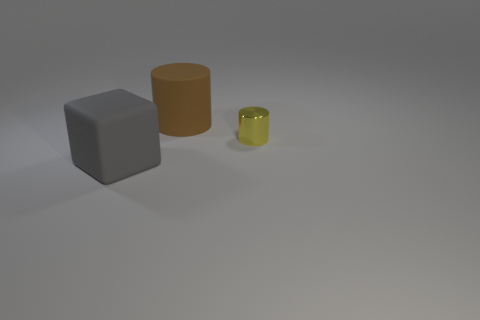The large rubber object that is behind the large block has what shape?
Provide a succinct answer. Cylinder. What is the gray cube made of?
Make the answer very short. Rubber. What is the color of the cylinder that is the same size as the gray block?
Provide a succinct answer. Brown. Does the large brown rubber object have the same shape as the small object?
Provide a short and direct response. Yes. The object that is both in front of the brown rubber cylinder and on the right side of the gray cube is made of what material?
Provide a succinct answer. Metal. The yellow metal object has what size?
Your response must be concise. Small. There is another rubber thing that is the same shape as the yellow object; what color is it?
Provide a succinct answer. Brown. Does the cylinder that is to the left of the small metal object have the same size as the object in front of the shiny cylinder?
Give a very brief answer. Yes. Are there an equal number of tiny metal objects in front of the large matte block and large rubber cubes in front of the big brown thing?
Offer a very short reply. No. Does the matte cylinder have the same size as the yellow cylinder to the right of the gray object?
Keep it short and to the point. No. 